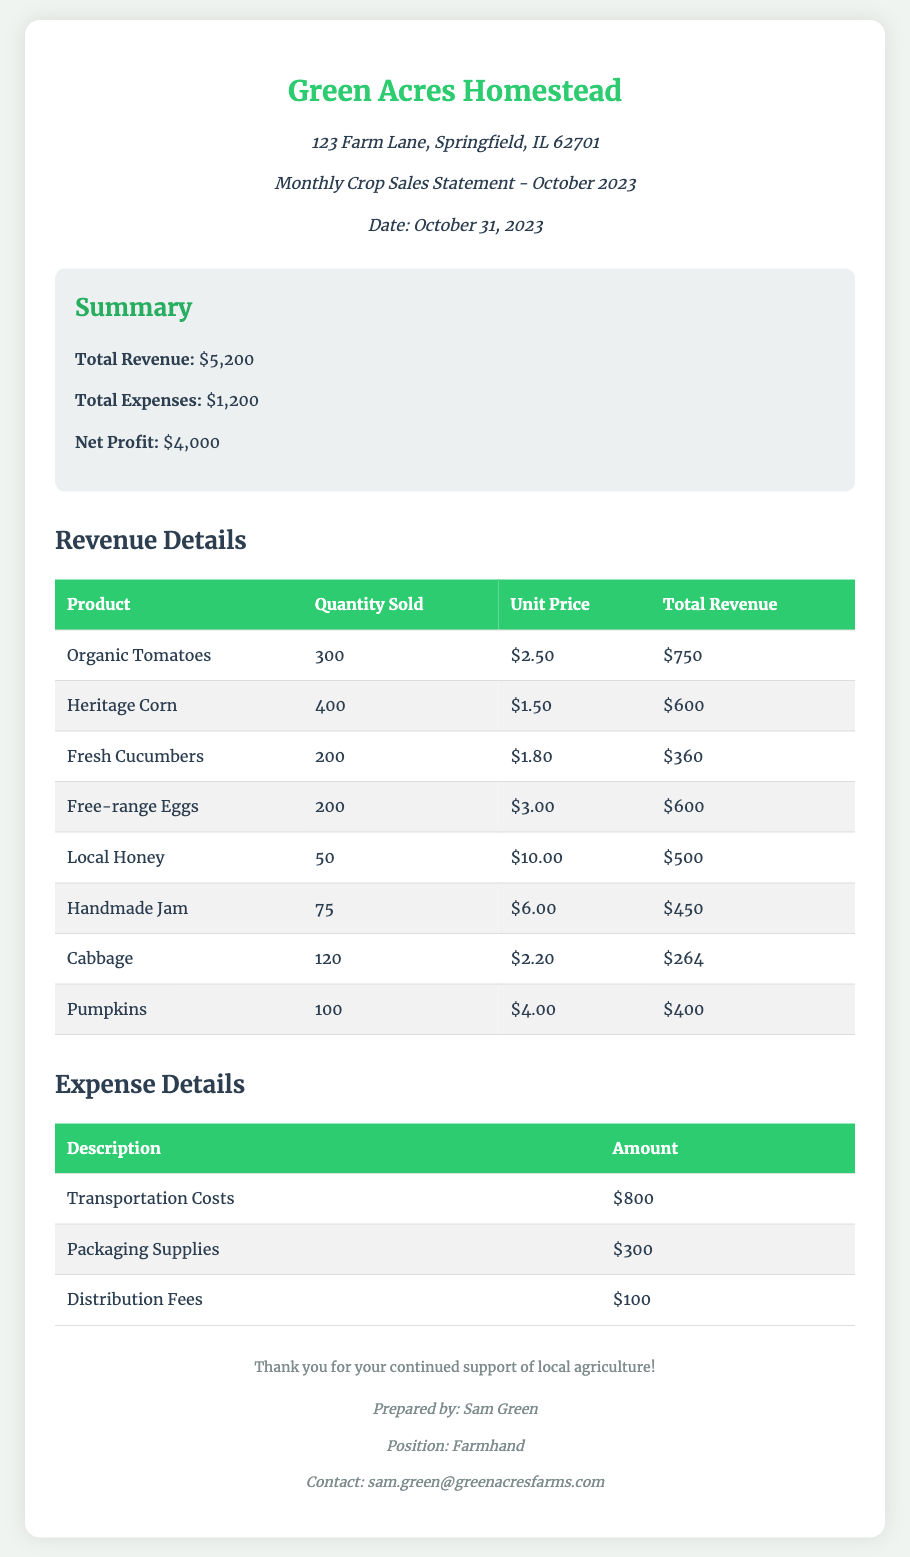what is the total revenue? The total revenue is provided in the summary section of the document, which is $5,200.
Answer: $5,200 what is the net profit? The net profit is calculated by subtracting total expenses from total revenue, which is $5,200 - $1,200 = $4,000.
Answer: $4,000 how many organic tomatoes were sold? The quantity of organic tomatoes sold is listed under revenue details, which is 300.
Answer: 300 what are the transportation costs? The transportation costs are specified in the expense details, which amount to $800.
Answer: $800 which product generated the highest revenue? The product with the highest total revenue is organic tomatoes with a total revenue of $750.
Answer: Organic Tomatoes what is the total expense amount? The total expenses are summed up in the summary section, which is $1,200.
Answer: $1,200 how many products were listed in the revenue details? There are eight products listed in the revenue details section of the document.
Answer: Eight who prepared the document? The document is prepared by Sam Green, as indicated in the footer.
Answer: Sam Green 